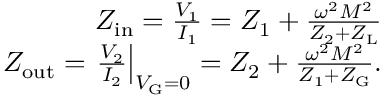Convert formula to latex. <formula><loc_0><loc_0><loc_500><loc_500>\begin{array} { r } { Z _ { i n } = \frac { V _ { 1 } } { I _ { 1 } } = Z _ { 1 } + \frac { \omega ^ { 2 } M ^ { 2 } } { Z _ { 2 } + Z _ { L } } } \\ { Z _ { o u t } = \frac { V _ { 2 } } { I _ { 2 } } \right | _ { V _ { G } = 0 } = Z _ { 2 } + \frac { \omega ^ { 2 } M ^ { 2 } } { Z _ { 1 } + Z _ { G } } . } \end{array}</formula> 